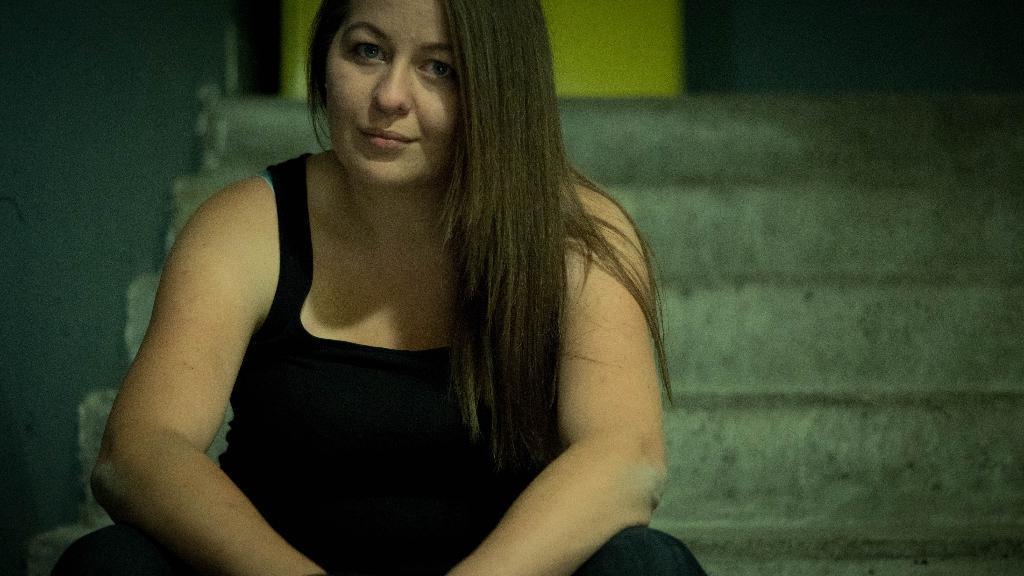Could you give a brief overview of what you see in this image? In the image there is a woman,she is wearing a black dress and she is posing for the photograph and she is sitting on the stairs. 